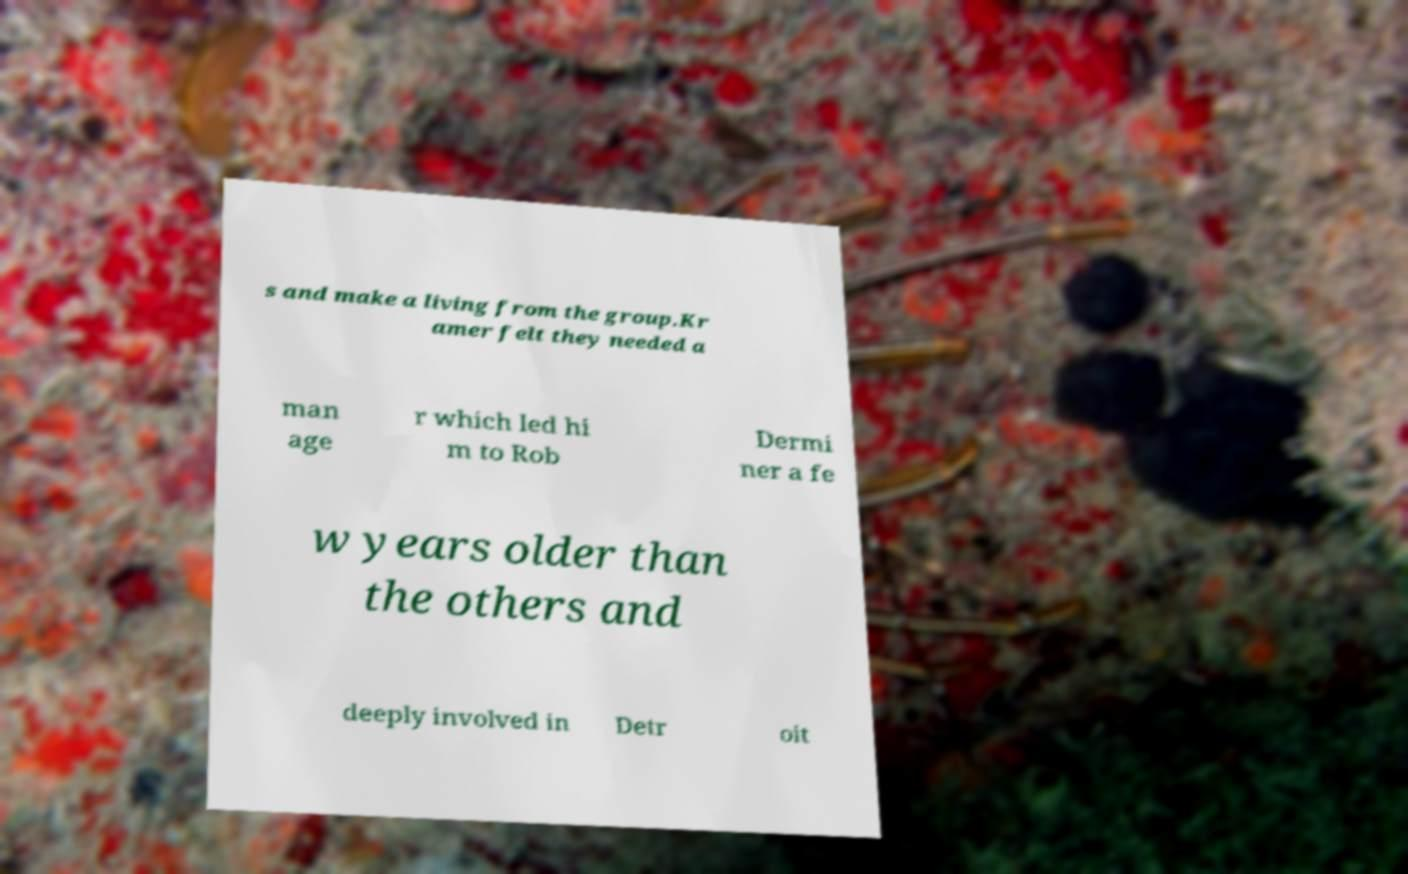Could you extract and type out the text from this image? s and make a living from the group.Kr amer felt they needed a man age r which led hi m to Rob Dermi ner a fe w years older than the others and deeply involved in Detr oit 